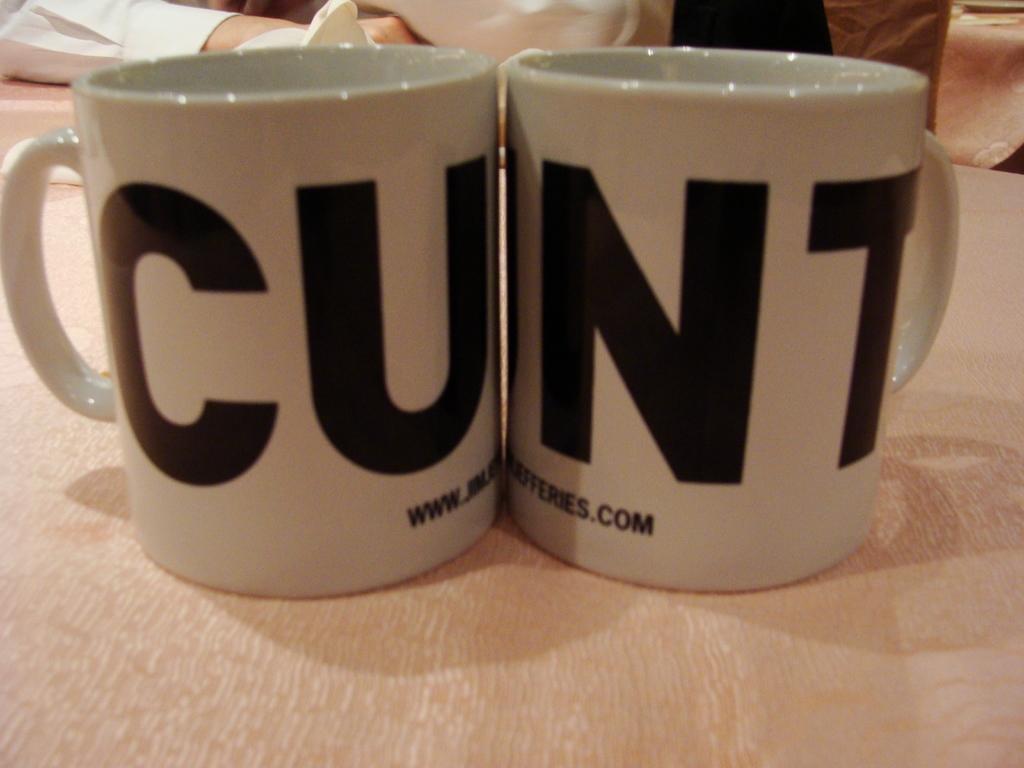What does the cup on the left say?
Offer a terse response. Cu. What do the two cups say when put together?
Offer a terse response. Cunt. 